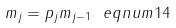<formula> <loc_0><loc_0><loc_500><loc_500>m _ { j } = p _ { j } m _ { j - 1 } \ e q n u m { 1 4 }</formula> 